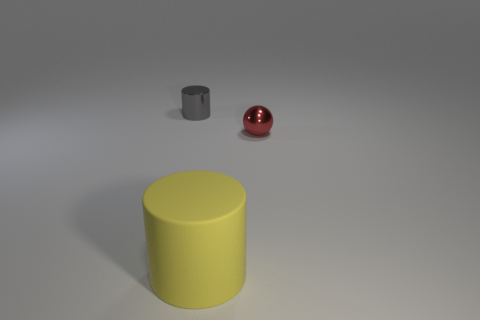Add 3 red shiny spheres. How many objects exist? 6 Subtract 0 yellow spheres. How many objects are left? 3 Subtract all balls. How many objects are left? 2 Subtract all red metallic balls. Subtract all gray things. How many objects are left? 1 Add 1 red things. How many red things are left? 2 Add 2 metallic objects. How many metallic objects exist? 4 